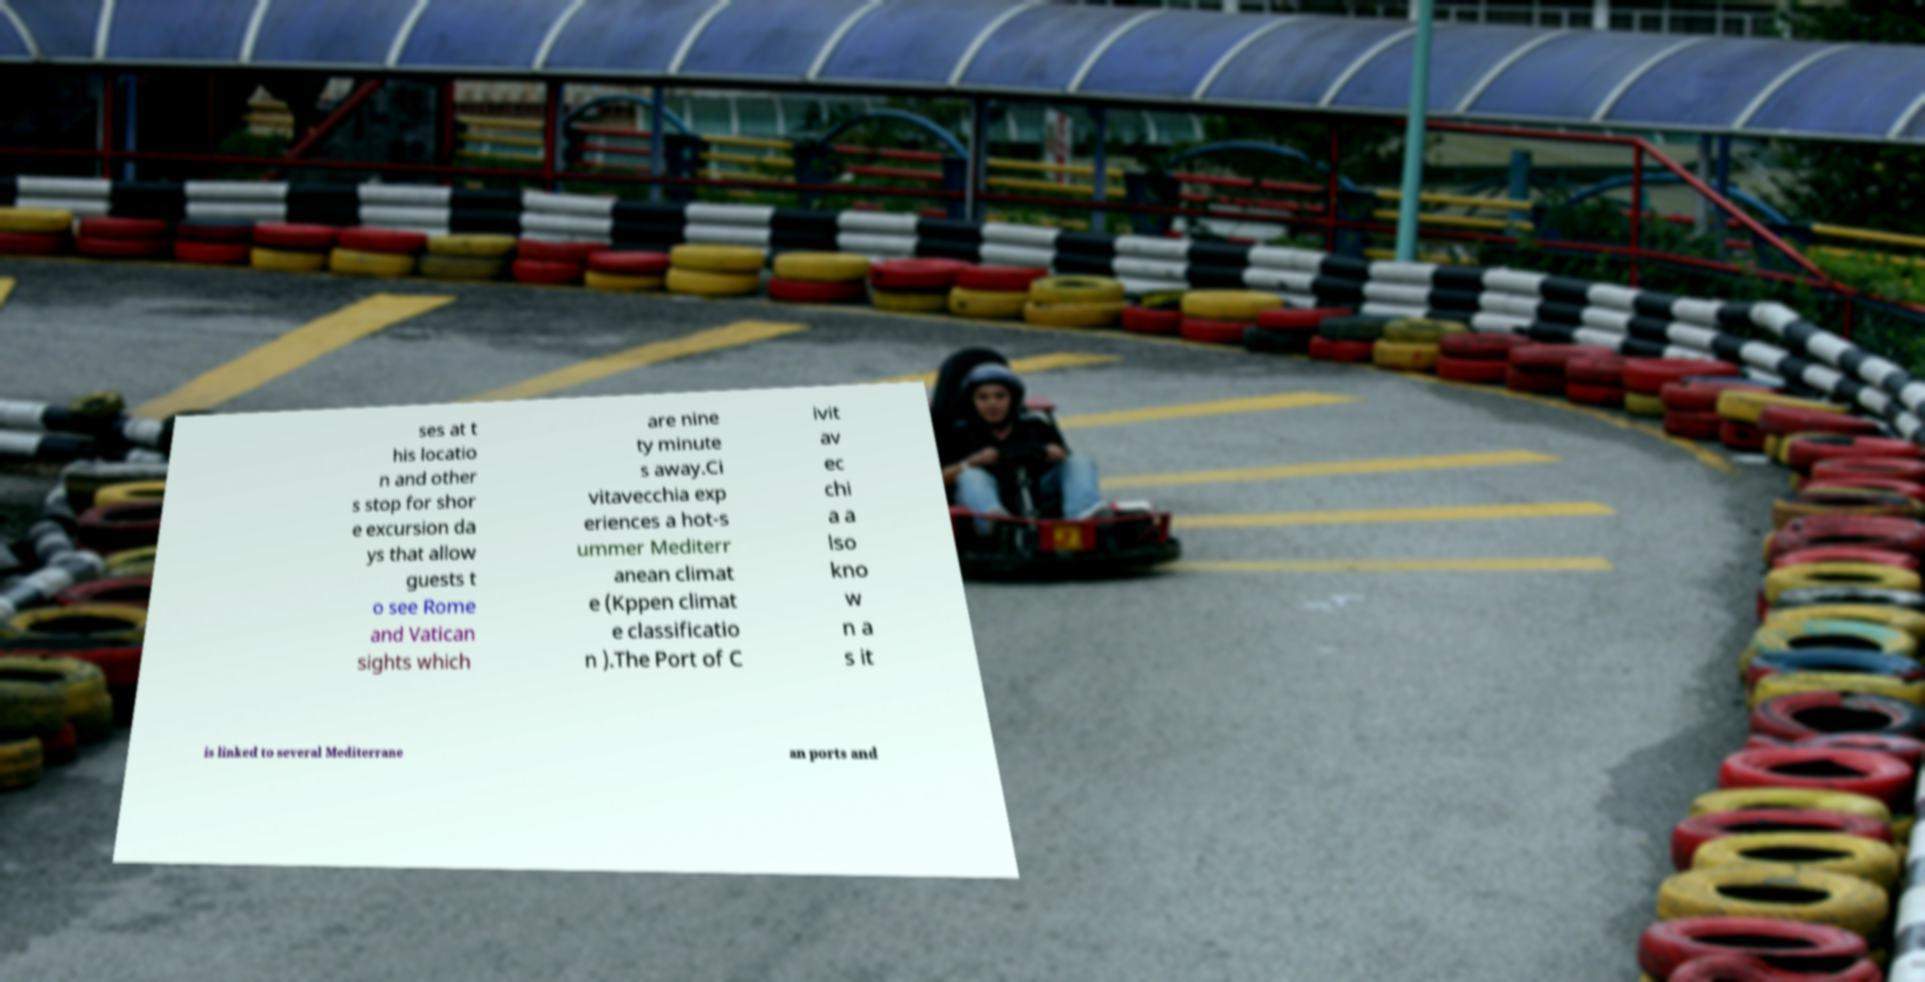What messages or text are displayed in this image? I need them in a readable, typed format. ses at t his locatio n and other s stop for shor e excursion da ys that allow guests t o see Rome and Vatican sights which are nine ty minute s away.Ci vitavecchia exp eriences a hot-s ummer Mediterr anean climat e (Kppen climat e classificatio n ).The Port of C ivit av ec chi a a lso kno w n a s it is linked to several Mediterrane an ports and 